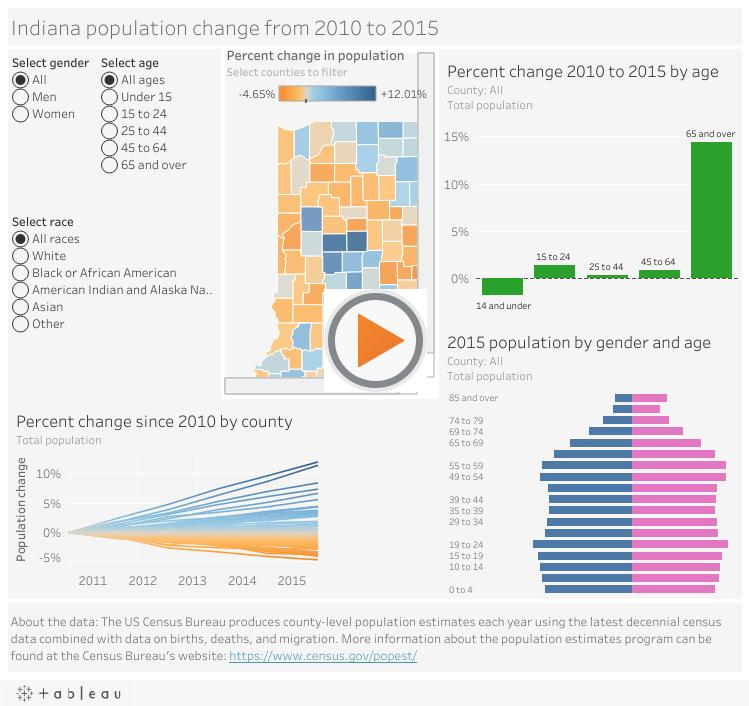Point out several critical features in this image. The number of age groups not selected in this infographic is 5. The number of races not selected in this infographic is five. 